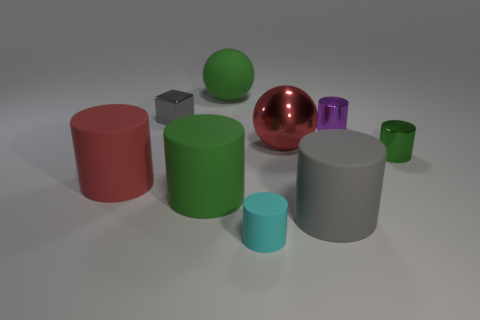Subtract all rubber cylinders. How many cylinders are left? 2 Subtract all cyan cylinders. How many cylinders are left? 5 Add 1 small gray shiny objects. How many objects exist? 10 Subtract all purple blocks. Subtract all big red metal spheres. How many objects are left? 8 Add 3 tiny purple cylinders. How many tiny purple cylinders are left? 4 Add 6 large green cylinders. How many large green cylinders exist? 7 Subtract 2 green cylinders. How many objects are left? 7 Subtract all cubes. How many objects are left? 8 Subtract 2 balls. How many balls are left? 0 Subtract all blue spheres. Subtract all green cylinders. How many spheres are left? 2 